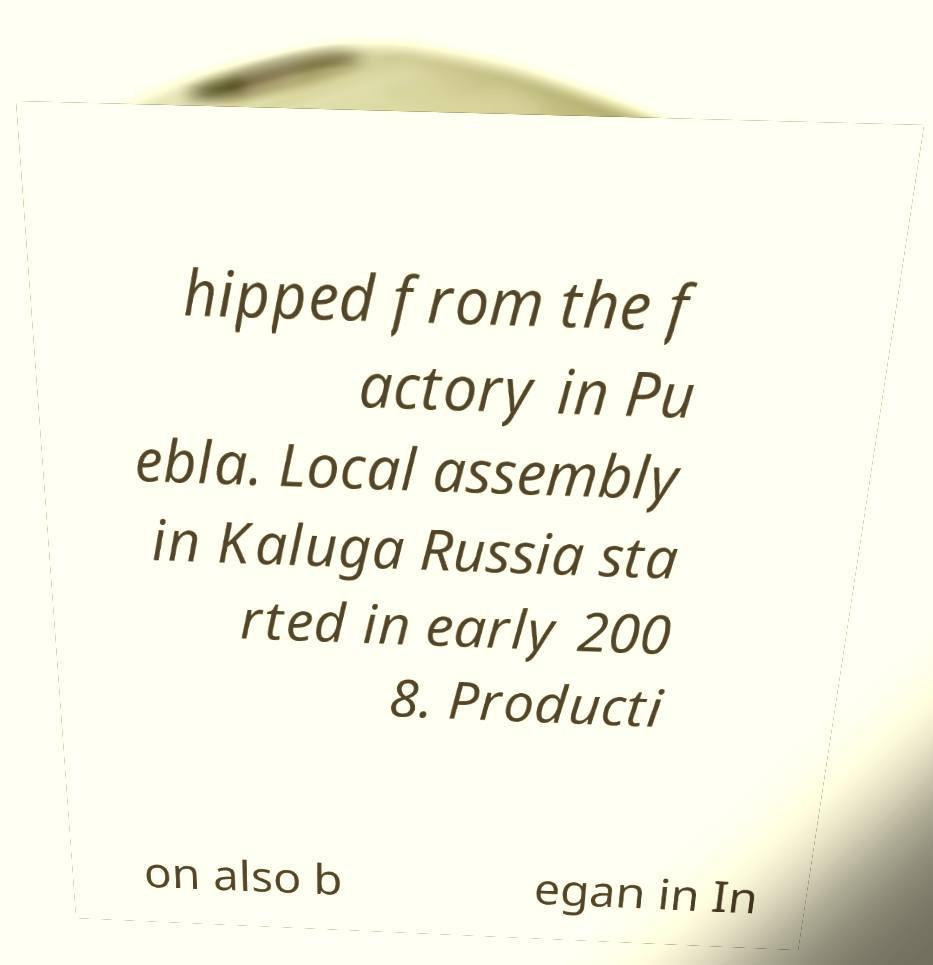Could you extract and type out the text from this image? hipped from the f actory in Pu ebla. Local assembly in Kaluga Russia sta rted in early 200 8. Producti on also b egan in In 